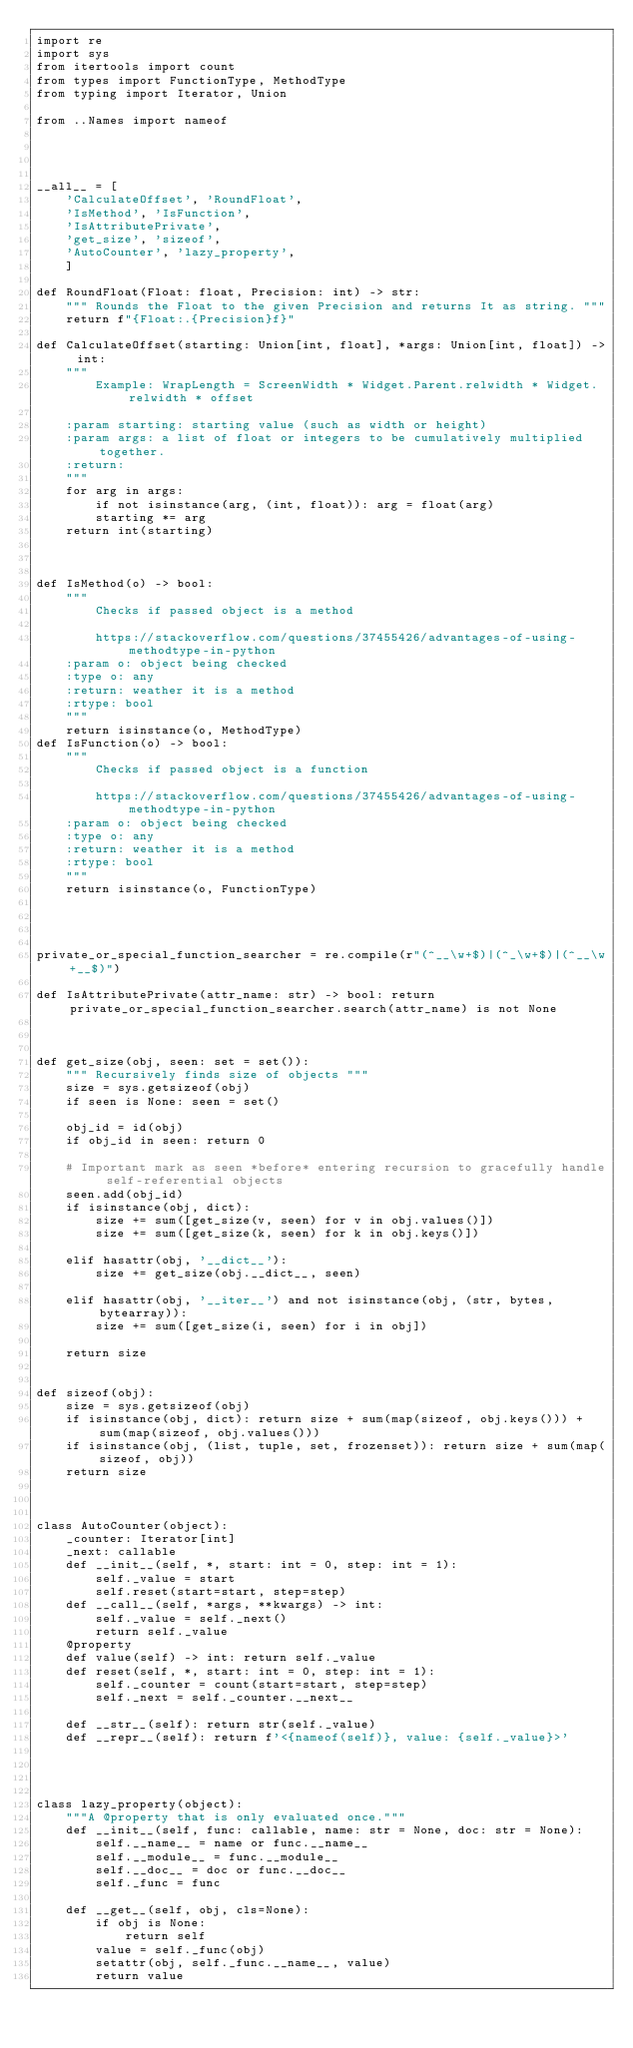Convert code to text. <code><loc_0><loc_0><loc_500><loc_500><_Python_>import re
import sys
from itertools import count
from types import FunctionType, MethodType
from typing import Iterator, Union

from ..Names import nameof




__all__ = [
    'CalculateOffset', 'RoundFloat',
    'IsMethod', 'IsFunction',
    'IsAttributePrivate',
    'get_size', 'sizeof',
    'AutoCounter', 'lazy_property',
    ]

def RoundFloat(Float: float, Precision: int) -> str:
    """ Rounds the Float to the given Precision and returns It as string. """
    return f"{Float:.{Precision}f}"

def CalculateOffset(starting: Union[int, float], *args: Union[int, float]) -> int:
    """
        Example: WrapLength = ScreenWidth * Widget.Parent.relwidth * Widget.relwidth * offset

    :param starting: starting value (such as width or height)
    :param args: a list of float or integers to be cumulatively multiplied together.
    :return:
    """
    for arg in args:
        if not isinstance(arg, (int, float)): arg = float(arg)
        starting *= arg
    return int(starting)



def IsMethod(o) -> bool:
    """
        Checks if passed object is a method

        https://stackoverflow.com/questions/37455426/advantages-of-using-methodtype-in-python
    :param o: object being checked
    :type o: any
    :return: weather it is a method
    :rtype: bool
    """
    return isinstance(o, MethodType)
def IsFunction(o) -> bool:
    """
        Checks if passed object is a function

        https://stackoverflow.com/questions/37455426/advantages-of-using-methodtype-in-python
    :param o: object being checked
    :type o: any
    :return: weather it is a method
    :rtype: bool
    """
    return isinstance(o, FunctionType)




private_or_special_function_searcher = re.compile(r"(^__\w+$)|(^_\w+$)|(^__\w+__$)")

def IsAttributePrivate(attr_name: str) -> bool: return private_or_special_function_searcher.search(attr_name) is not None



def get_size(obj, seen: set = set()):
    """ Recursively finds size of objects """
    size = sys.getsizeof(obj)
    if seen is None: seen = set()

    obj_id = id(obj)
    if obj_id in seen: return 0

    # Important mark as seen *before* entering recursion to gracefully handle self-referential objects
    seen.add(obj_id)
    if isinstance(obj, dict):
        size += sum([get_size(v, seen) for v in obj.values()])
        size += sum([get_size(k, seen) for k in obj.keys()])

    elif hasattr(obj, '__dict__'):
        size += get_size(obj.__dict__, seen)

    elif hasattr(obj, '__iter__') and not isinstance(obj, (str, bytes, bytearray)):
        size += sum([get_size(i, seen) for i in obj])

    return size


def sizeof(obj):
    size = sys.getsizeof(obj)
    if isinstance(obj, dict): return size + sum(map(sizeof, obj.keys())) + sum(map(sizeof, obj.values()))
    if isinstance(obj, (list, tuple, set, frozenset)): return size + sum(map(sizeof, obj))
    return size



class AutoCounter(object):
    _counter: Iterator[int]
    _next: callable
    def __init__(self, *, start: int = 0, step: int = 1):
        self._value = start
        self.reset(start=start, step=step)
    def __call__(self, *args, **kwargs) -> int:
        self._value = self._next()
        return self._value
    @property
    def value(self) -> int: return self._value
    def reset(self, *, start: int = 0, step: int = 1):
        self._counter = count(start=start, step=step)
        self._next = self._counter.__next__

    def __str__(self): return str(self._value)
    def __repr__(self): return f'<{nameof(self)}, value: {self._value}>'




class lazy_property(object):
    """A @property that is only evaluated once."""
    def __init__(self, func: callable, name: str = None, doc: str = None):
        self.__name__ = name or func.__name__
        self.__module__ = func.__module__
        self.__doc__ = doc or func.__doc__
        self._func = func

    def __get__(self, obj, cls=None):
        if obj is None:
            return self
        value = self._func(obj)
        setattr(obj, self._func.__name__, value)
        return value
</code> 